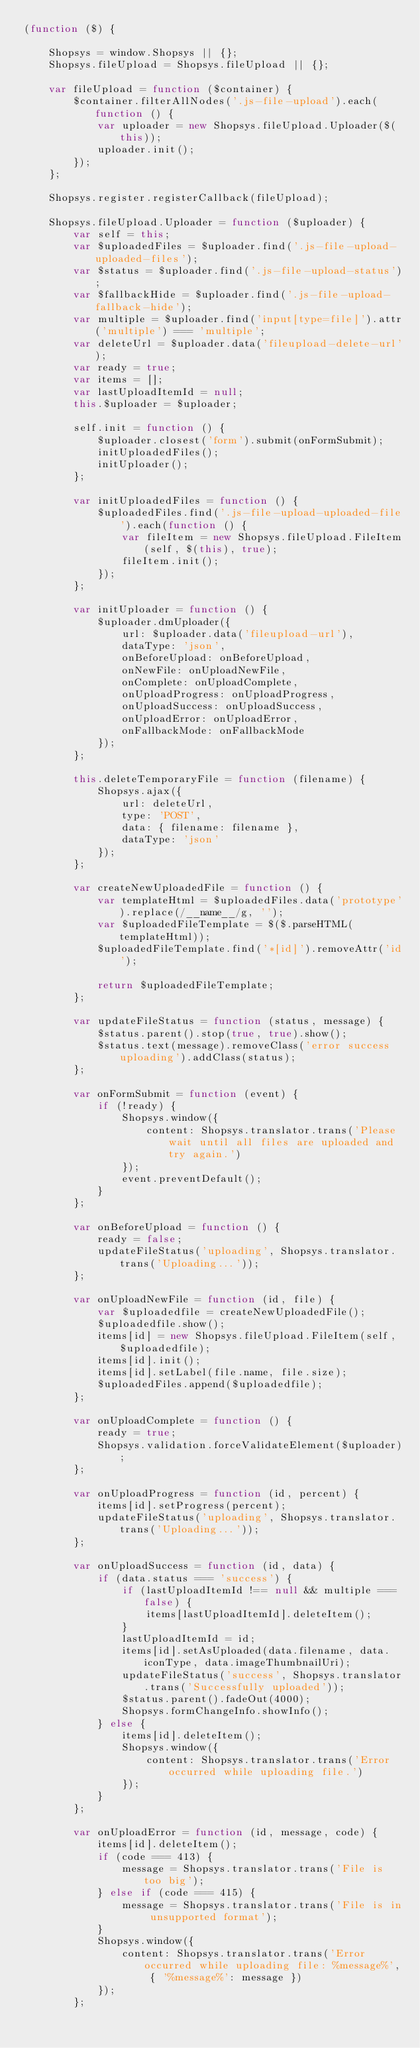<code> <loc_0><loc_0><loc_500><loc_500><_JavaScript_>(function ($) {

    Shopsys = window.Shopsys || {};
    Shopsys.fileUpload = Shopsys.fileUpload || {};

    var fileUpload = function ($container) {
        $container.filterAllNodes('.js-file-upload').each(function () {
            var uploader = new Shopsys.fileUpload.Uploader($(this));
            uploader.init();
        });
    };

    Shopsys.register.registerCallback(fileUpload);

    Shopsys.fileUpload.Uploader = function ($uploader) {
        var self = this;
        var $uploadedFiles = $uploader.find('.js-file-upload-uploaded-files');
        var $status = $uploader.find('.js-file-upload-status');
        var $fallbackHide = $uploader.find('.js-file-upload-fallback-hide');
        var multiple = $uploader.find('input[type=file]').attr('multiple') === 'multiple';
        var deleteUrl = $uploader.data('fileupload-delete-url');
        var ready = true;
        var items = [];
        var lastUploadItemId = null;
        this.$uploader = $uploader;

        self.init = function () {
            $uploader.closest('form').submit(onFormSubmit);
            initUploadedFiles();
            initUploader();
        };

        var initUploadedFiles = function () {
            $uploadedFiles.find('.js-file-upload-uploaded-file').each(function () {
                var fileItem = new Shopsys.fileUpload.FileItem(self, $(this), true);
                fileItem.init();
            });
        };

        var initUploader = function () {
            $uploader.dmUploader({
                url: $uploader.data('fileupload-url'),
                dataType: 'json',
                onBeforeUpload: onBeforeUpload,
                onNewFile: onUploadNewFile,
                onComplete: onUploadComplete,
                onUploadProgress: onUploadProgress,
                onUploadSuccess: onUploadSuccess,
                onUploadError: onUploadError,
                onFallbackMode: onFallbackMode
            });
        };

        this.deleteTemporaryFile = function (filename) {
            Shopsys.ajax({
                url: deleteUrl,
                type: 'POST',
                data: { filename: filename },
                dataType: 'json'
            });
        };

        var createNewUploadedFile = function () {
            var templateHtml = $uploadedFiles.data('prototype').replace(/__name__/g, '');
            var $uploadedFileTemplate = $($.parseHTML(templateHtml));
            $uploadedFileTemplate.find('*[id]').removeAttr('id');

            return $uploadedFileTemplate;
        };

        var updateFileStatus = function (status, message) {
            $status.parent().stop(true, true).show();
            $status.text(message).removeClass('error success uploading').addClass(status);
        };

        var onFormSubmit = function (event) {
            if (!ready) {
                Shopsys.window({
                    content: Shopsys.translator.trans('Please wait until all files are uploaded and try again.')
                });
                event.preventDefault();
            }
        };

        var onBeforeUpload = function () {
            ready = false;
            updateFileStatus('uploading', Shopsys.translator.trans('Uploading...'));
        };

        var onUploadNewFile = function (id, file) {
            var $uploadedfile = createNewUploadedFile();
            $uploadedfile.show();
            items[id] = new Shopsys.fileUpload.FileItem(self, $uploadedfile);
            items[id].init();
            items[id].setLabel(file.name, file.size);
            $uploadedFiles.append($uploadedfile);
        };

        var onUploadComplete = function () {
            ready = true;
            Shopsys.validation.forceValidateElement($uploader);
        };

        var onUploadProgress = function (id, percent) {
            items[id].setProgress(percent);
            updateFileStatus('uploading', Shopsys.translator.trans('Uploading...'));
        };

        var onUploadSuccess = function (id, data) {
            if (data.status === 'success') {
                if (lastUploadItemId !== null && multiple === false) {
                    items[lastUploadItemId].deleteItem();
                }
                lastUploadItemId = id;
                items[id].setAsUploaded(data.filename, data.iconType, data.imageThumbnailUri);
                updateFileStatus('success', Shopsys.translator.trans('Successfully uploaded'));
                $status.parent().fadeOut(4000);
                Shopsys.formChangeInfo.showInfo();
            } else {
                items[id].deleteItem();
                Shopsys.window({
                    content: Shopsys.translator.trans('Error occurred while uploading file.')
                });
            }
        };

        var onUploadError = function (id, message, code) {
            items[id].deleteItem();
            if (code === 413) {
                message = Shopsys.translator.trans('File is too big');
            } else if (code === 415) {
                message = Shopsys.translator.trans('File is in unsupported format');
            }
            Shopsys.window({
                content: Shopsys.translator.trans('Error occurred while uploading file: %message%', { '%message%': message })
            });
        };
</code> 